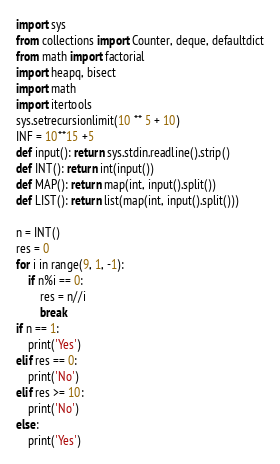Convert code to text. <code><loc_0><loc_0><loc_500><loc_500><_Python_>import sys
from collections import Counter, deque, defaultdict
from math import factorial
import heapq, bisect
import math
import itertools
sys.setrecursionlimit(10 ** 5 + 10)
INF = 10**15 +5
def input(): return sys.stdin.readline().strip()
def INT(): return int(input())
def MAP(): return map(int, input().split())
def LIST(): return list(map(int, input().split()))

n = INT()
res = 0
for i in range(9, 1, -1):
    if n%i == 0:
        res = n//i
        break
if n == 1:
    print('Yes')
elif res == 0:
    print('No')
elif res >= 10:
    print('No')
else:
    print('Yes')</code> 